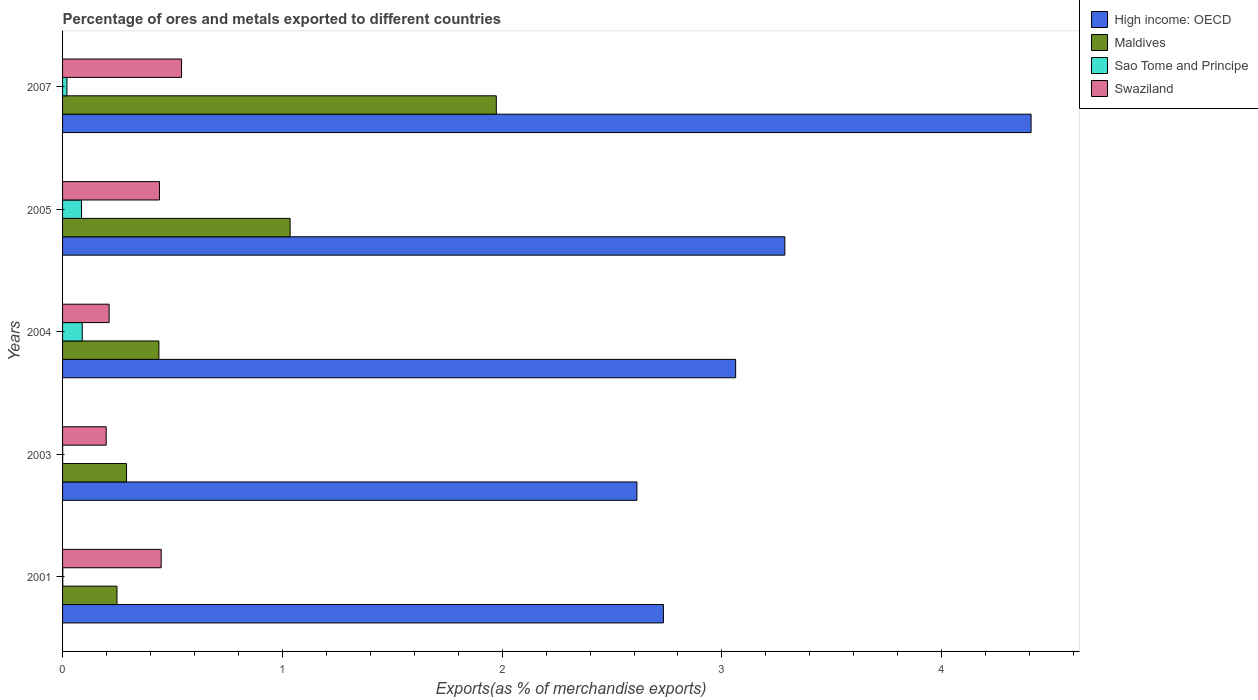How many different coloured bars are there?
Make the answer very short. 4. How many bars are there on the 4th tick from the top?
Provide a short and direct response. 4. How many bars are there on the 4th tick from the bottom?
Provide a short and direct response. 4. In how many cases, is the number of bars for a given year not equal to the number of legend labels?
Make the answer very short. 0. What is the percentage of exports to different countries in High income: OECD in 2007?
Provide a short and direct response. 4.41. Across all years, what is the maximum percentage of exports to different countries in Swaziland?
Your response must be concise. 0.54. Across all years, what is the minimum percentage of exports to different countries in Swaziland?
Offer a terse response. 0.2. In which year was the percentage of exports to different countries in Swaziland maximum?
Give a very brief answer. 2007. What is the total percentage of exports to different countries in Sao Tome and Principe in the graph?
Make the answer very short. 0.2. What is the difference between the percentage of exports to different countries in Swaziland in 2003 and that in 2004?
Ensure brevity in your answer.  -0.01. What is the difference between the percentage of exports to different countries in Swaziland in 2001 and the percentage of exports to different countries in Maldives in 2003?
Offer a terse response. 0.16. What is the average percentage of exports to different countries in High income: OECD per year?
Provide a short and direct response. 3.22. In the year 2003, what is the difference between the percentage of exports to different countries in Swaziland and percentage of exports to different countries in Maldives?
Keep it short and to the point. -0.09. What is the ratio of the percentage of exports to different countries in High income: OECD in 2001 to that in 2003?
Offer a very short reply. 1.05. What is the difference between the highest and the second highest percentage of exports to different countries in Sao Tome and Principe?
Your answer should be very brief. 0. What is the difference between the highest and the lowest percentage of exports to different countries in Swaziland?
Make the answer very short. 0.34. Is the sum of the percentage of exports to different countries in Maldives in 2001 and 2004 greater than the maximum percentage of exports to different countries in High income: OECD across all years?
Offer a very short reply. No. Is it the case that in every year, the sum of the percentage of exports to different countries in Sao Tome and Principe and percentage of exports to different countries in High income: OECD is greater than the sum of percentage of exports to different countries in Maldives and percentage of exports to different countries in Swaziland?
Keep it short and to the point. Yes. What does the 2nd bar from the top in 2004 represents?
Offer a very short reply. Sao Tome and Principe. What does the 1st bar from the bottom in 2007 represents?
Provide a succinct answer. High income: OECD. Is it the case that in every year, the sum of the percentage of exports to different countries in Swaziland and percentage of exports to different countries in Maldives is greater than the percentage of exports to different countries in Sao Tome and Principe?
Offer a very short reply. Yes. How many bars are there?
Give a very brief answer. 20. How many legend labels are there?
Make the answer very short. 4. What is the title of the graph?
Offer a very short reply. Percentage of ores and metals exported to different countries. What is the label or title of the X-axis?
Ensure brevity in your answer.  Exports(as % of merchandise exports). What is the label or title of the Y-axis?
Ensure brevity in your answer.  Years. What is the Exports(as % of merchandise exports) in High income: OECD in 2001?
Offer a terse response. 2.73. What is the Exports(as % of merchandise exports) of Maldives in 2001?
Your response must be concise. 0.25. What is the Exports(as % of merchandise exports) of Sao Tome and Principe in 2001?
Your response must be concise. 0. What is the Exports(as % of merchandise exports) in Swaziland in 2001?
Provide a succinct answer. 0.45. What is the Exports(as % of merchandise exports) of High income: OECD in 2003?
Ensure brevity in your answer.  2.61. What is the Exports(as % of merchandise exports) in Maldives in 2003?
Keep it short and to the point. 0.29. What is the Exports(as % of merchandise exports) of Sao Tome and Principe in 2003?
Ensure brevity in your answer.  0. What is the Exports(as % of merchandise exports) in Swaziland in 2003?
Ensure brevity in your answer.  0.2. What is the Exports(as % of merchandise exports) of High income: OECD in 2004?
Make the answer very short. 3.06. What is the Exports(as % of merchandise exports) of Maldives in 2004?
Offer a terse response. 0.44. What is the Exports(as % of merchandise exports) of Sao Tome and Principe in 2004?
Ensure brevity in your answer.  0.09. What is the Exports(as % of merchandise exports) of Swaziland in 2004?
Offer a terse response. 0.21. What is the Exports(as % of merchandise exports) in High income: OECD in 2005?
Your response must be concise. 3.29. What is the Exports(as % of merchandise exports) of Maldives in 2005?
Your answer should be very brief. 1.04. What is the Exports(as % of merchandise exports) in Sao Tome and Principe in 2005?
Offer a terse response. 0.09. What is the Exports(as % of merchandise exports) of Swaziland in 2005?
Give a very brief answer. 0.44. What is the Exports(as % of merchandise exports) in High income: OECD in 2007?
Your answer should be very brief. 4.41. What is the Exports(as % of merchandise exports) in Maldives in 2007?
Give a very brief answer. 1.97. What is the Exports(as % of merchandise exports) of Sao Tome and Principe in 2007?
Your response must be concise. 0.02. What is the Exports(as % of merchandise exports) in Swaziland in 2007?
Make the answer very short. 0.54. Across all years, what is the maximum Exports(as % of merchandise exports) of High income: OECD?
Your answer should be very brief. 4.41. Across all years, what is the maximum Exports(as % of merchandise exports) of Maldives?
Make the answer very short. 1.97. Across all years, what is the maximum Exports(as % of merchandise exports) in Sao Tome and Principe?
Your response must be concise. 0.09. Across all years, what is the maximum Exports(as % of merchandise exports) in Swaziland?
Keep it short and to the point. 0.54. Across all years, what is the minimum Exports(as % of merchandise exports) of High income: OECD?
Offer a terse response. 2.61. Across all years, what is the minimum Exports(as % of merchandise exports) in Maldives?
Offer a terse response. 0.25. Across all years, what is the minimum Exports(as % of merchandise exports) in Sao Tome and Principe?
Your answer should be compact. 0. Across all years, what is the minimum Exports(as % of merchandise exports) in Swaziland?
Give a very brief answer. 0.2. What is the total Exports(as % of merchandise exports) of High income: OECD in the graph?
Offer a very short reply. 16.1. What is the total Exports(as % of merchandise exports) in Maldives in the graph?
Your response must be concise. 3.99. What is the total Exports(as % of merchandise exports) of Sao Tome and Principe in the graph?
Your response must be concise. 0.2. What is the total Exports(as % of merchandise exports) in Swaziland in the graph?
Your answer should be very brief. 1.84. What is the difference between the Exports(as % of merchandise exports) of High income: OECD in 2001 and that in 2003?
Offer a very short reply. 0.12. What is the difference between the Exports(as % of merchandise exports) of Maldives in 2001 and that in 2003?
Ensure brevity in your answer.  -0.04. What is the difference between the Exports(as % of merchandise exports) of Sao Tome and Principe in 2001 and that in 2003?
Your answer should be compact. 0. What is the difference between the Exports(as % of merchandise exports) of Swaziland in 2001 and that in 2003?
Give a very brief answer. 0.25. What is the difference between the Exports(as % of merchandise exports) in High income: OECD in 2001 and that in 2004?
Your answer should be very brief. -0.33. What is the difference between the Exports(as % of merchandise exports) in Maldives in 2001 and that in 2004?
Provide a short and direct response. -0.19. What is the difference between the Exports(as % of merchandise exports) in Sao Tome and Principe in 2001 and that in 2004?
Your answer should be very brief. -0.09. What is the difference between the Exports(as % of merchandise exports) of Swaziland in 2001 and that in 2004?
Make the answer very short. 0.24. What is the difference between the Exports(as % of merchandise exports) in High income: OECD in 2001 and that in 2005?
Keep it short and to the point. -0.55. What is the difference between the Exports(as % of merchandise exports) in Maldives in 2001 and that in 2005?
Your response must be concise. -0.79. What is the difference between the Exports(as % of merchandise exports) in Sao Tome and Principe in 2001 and that in 2005?
Offer a terse response. -0.09. What is the difference between the Exports(as % of merchandise exports) in Swaziland in 2001 and that in 2005?
Make the answer very short. 0.01. What is the difference between the Exports(as % of merchandise exports) of High income: OECD in 2001 and that in 2007?
Offer a terse response. -1.67. What is the difference between the Exports(as % of merchandise exports) of Maldives in 2001 and that in 2007?
Your answer should be very brief. -1.73. What is the difference between the Exports(as % of merchandise exports) of Sao Tome and Principe in 2001 and that in 2007?
Offer a terse response. -0.02. What is the difference between the Exports(as % of merchandise exports) of Swaziland in 2001 and that in 2007?
Make the answer very short. -0.09. What is the difference between the Exports(as % of merchandise exports) of High income: OECD in 2003 and that in 2004?
Give a very brief answer. -0.45. What is the difference between the Exports(as % of merchandise exports) of Maldives in 2003 and that in 2004?
Offer a terse response. -0.15. What is the difference between the Exports(as % of merchandise exports) of Sao Tome and Principe in 2003 and that in 2004?
Ensure brevity in your answer.  -0.09. What is the difference between the Exports(as % of merchandise exports) of Swaziland in 2003 and that in 2004?
Provide a short and direct response. -0.01. What is the difference between the Exports(as % of merchandise exports) in High income: OECD in 2003 and that in 2005?
Offer a terse response. -0.67. What is the difference between the Exports(as % of merchandise exports) in Maldives in 2003 and that in 2005?
Offer a terse response. -0.74. What is the difference between the Exports(as % of merchandise exports) in Sao Tome and Principe in 2003 and that in 2005?
Your answer should be very brief. -0.09. What is the difference between the Exports(as % of merchandise exports) of Swaziland in 2003 and that in 2005?
Offer a very short reply. -0.24. What is the difference between the Exports(as % of merchandise exports) in High income: OECD in 2003 and that in 2007?
Give a very brief answer. -1.79. What is the difference between the Exports(as % of merchandise exports) in Maldives in 2003 and that in 2007?
Make the answer very short. -1.68. What is the difference between the Exports(as % of merchandise exports) of Sao Tome and Principe in 2003 and that in 2007?
Your answer should be very brief. -0.02. What is the difference between the Exports(as % of merchandise exports) in Swaziland in 2003 and that in 2007?
Offer a very short reply. -0.34. What is the difference between the Exports(as % of merchandise exports) in High income: OECD in 2004 and that in 2005?
Your answer should be compact. -0.22. What is the difference between the Exports(as % of merchandise exports) in Maldives in 2004 and that in 2005?
Make the answer very short. -0.6. What is the difference between the Exports(as % of merchandise exports) in Sao Tome and Principe in 2004 and that in 2005?
Keep it short and to the point. 0. What is the difference between the Exports(as % of merchandise exports) of Swaziland in 2004 and that in 2005?
Offer a very short reply. -0.23. What is the difference between the Exports(as % of merchandise exports) of High income: OECD in 2004 and that in 2007?
Ensure brevity in your answer.  -1.34. What is the difference between the Exports(as % of merchandise exports) of Maldives in 2004 and that in 2007?
Give a very brief answer. -1.54. What is the difference between the Exports(as % of merchandise exports) in Sao Tome and Principe in 2004 and that in 2007?
Your answer should be compact. 0.07. What is the difference between the Exports(as % of merchandise exports) in Swaziland in 2004 and that in 2007?
Keep it short and to the point. -0.33. What is the difference between the Exports(as % of merchandise exports) of High income: OECD in 2005 and that in 2007?
Your answer should be compact. -1.12. What is the difference between the Exports(as % of merchandise exports) of Maldives in 2005 and that in 2007?
Offer a very short reply. -0.94. What is the difference between the Exports(as % of merchandise exports) of Sao Tome and Principe in 2005 and that in 2007?
Your answer should be compact. 0.07. What is the difference between the Exports(as % of merchandise exports) in Swaziland in 2005 and that in 2007?
Provide a short and direct response. -0.1. What is the difference between the Exports(as % of merchandise exports) in High income: OECD in 2001 and the Exports(as % of merchandise exports) in Maldives in 2003?
Your response must be concise. 2.44. What is the difference between the Exports(as % of merchandise exports) in High income: OECD in 2001 and the Exports(as % of merchandise exports) in Sao Tome and Principe in 2003?
Give a very brief answer. 2.73. What is the difference between the Exports(as % of merchandise exports) in High income: OECD in 2001 and the Exports(as % of merchandise exports) in Swaziland in 2003?
Provide a short and direct response. 2.54. What is the difference between the Exports(as % of merchandise exports) of Maldives in 2001 and the Exports(as % of merchandise exports) of Sao Tome and Principe in 2003?
Provide a succinct answer. 0.25. What is the difference between the Exports(as % of merchandise exports) of Maldives in 2001 and the Exports(as % of merchandise exports) of Swaziland in 2003?
Provide a succinct answer. 0.05. What is the difference between the Exports(as % of merchandise exports) of Sao Tome and Principe in 2001 and the Exports(as % of merchandise exports) of Swaziland in 2003?
Make the answer very short. -0.2. What is the difference between the Exports(as % of merchandise exports) in High income: OECD in 2001 and the Exports(as % of merchandise exports) in Maldives in 2004?
Give a very brief answer. 2.3. What is the difference between the Exports(as % of merchandise exports) of High income: OECD in 2001 and the Exports(as % of merchandise exports) of Sao Tome and Principe in 2004?
Keep it short and to the point. 2.64. What is the difference between the Exports(as % of merchandise exports) in High income: OECD in 2001 and the Exports(as % of merchandise exports) in Swaziland in 2004?
Make the answer very short. 2.52. What is the difference between the Exports(as % of merchandise exports) of Maldives in 2001 and the Exports(as % of merchandise exports) of Sao Tome and Principe in 2004?
Your answer should be very brief. 0.16. What is the difference between the Exports(as % of merchandise exports) in Maldives in 2001 and the Exports(as % of merchandise exports) in Swaziland in 2004?
Ensure brevity in your answer.  0.04. What is the difference between the Exports(as % of merchandise exports) of Sao Tome and Principe in 2001 and the Exports(as % of merchandise exports) of Swaziland in 2004?
Your answer should be compact. -0.21. What is the difference between the Exports(as % of merchandise exports) of High income: OECD in 2001 and the Exports(as % of merchandise exports) of Maldives in 2005?
Keep it short and to the point. 1.7. What is the difference between the Exports(as % of merchandise exports) of High income: OECD in 2001 and the Exports(as % of merchandise exports) of Sao Tome and Principe in 2005?
Provide a short and direct response. 2.65. What is the difference between the Exports(as % of merchandise exports) in High income: OECD in 2001 and the Exports(as % of merchandise exports) in Swaziland in 2005?
Make the answer very short. 2.29. What is the difference between the Exports(as % of merchandise exports) of Maldives in 2001 and the Exports(as % of merchandise exports) of Sao Tome and Principe in 2005?
Your response must be concise. 0.16. What is the difference between the Exports(as % of merchandise exports) of Maldives in 2001 and the Exports(as % of merchandise exports) of Swaziland in 2005?
Your answer should be compact. -0.19. What is the difference between the Exports(as % of merchandise exports) of Sao Tome and Principe in 2001 and the Exports(as % of merchandise exports) of Swaziland in 2005?
Offer a very short reply. -0.44. What is the difference between the Exports(as % of merchandise exports) in High income: OECD in 2001 and the Exports(as % of merchandise exports) in Maldives in 2007?
Your response must be concise. 0.76. What is the difference between the Exports(as % of merchandise exports) of High income: OECD in 2001 and the Exports(as % of merchandise exports) of Sao Tome and Principe in 2007?
Offer a terse response. 2.71. What is the difference between the Exports(as % of merchandise exports) in High income: OECD in 2001 and the Exports(as % of merchandise exports) in Swaziland in 2007?
Offer a terse response. 2.19. What is the difference between the Exports(as % of merchandise exports) of Maldives in 2001 and the Exports(as % of merchandise exports) of Sao Tome and Principe in 2007?
Your response must be concise. 0.23. What is the difference between the Exports(as % of merchandise exports) of Maldives in 2001 and the Exports(as % of merchandise exports) of Swaziland in 2007?
Your response must be concise. -0.29. What is the difference between the Exports(as % of merchandise exports) in Sao Tome and Principe in 2001 and the Exports(as % of merchandise exports) in Swaziland in 2007?
Ensure brevity in your answer.  -0.54. What is the difference between the Exports(as % of merchandise exports) in High income: OECD in 2003 and the Exports(as % of merchandise exports) in Maldives in 2004?
Your answer should be compact. 2.17. What is the difference between the Exports(as % of merchandise exports) in High income: OECD in 2003 and the Exports(as % of merchandise exports) in Sao Tome and Principe in 2004?
Offer a very short reply. 2.52. What is the difference between the Exports(as % of merchandise exports) in High income: OECD in 2003 and the Exports(as % of merchandise exports) in Swaziland in 2004?
Provide a short and direct response. 2.4. What is the difference between the Exports(as % of merchandise exports) of Maldives in 2003 and the Exports(as % of merchandise exports) of Sao Tome and Principe in 2004?
Provide a short and direct response. 0.2. What is the difference between the Exports(as % of merchandise exports) in Maldives in 2003 and the Exports(as % of merchandise exports) in Swaziland in 2004?
Your answer should be compact. 0.08. What is the difference between the Exports(as % of merchandise exports) of Sao Tome and Principe in 2003 and the Exports(as % of merchandise exports) of Swaziland in 2004?
Provide a short and direct response. -0.21. What is the difference between the Exports(as % of merchandise exports) in High income: OECD in 2003 and the Exports(as % of merchandise exports) in Maldives in 2005?
Make the answer very short. 1.58. What is the difference between the Exports(as % of merchandise exports) of High income: OECD in 2003 and the Exports(as % of merchandise exports) of Sao Tome and Principe in 2005?
Ensure brevity in your answer.  2.53. What is the difference between the Exports(as % of merchandise exports) of High income: OECD in 2003 and the Exports(as % of merchandise exports) of Swaziland in 2005?
Offer a terse response. 2.17. What is the difference between the Exports(as % of merchandise exports) of Maldives in 2003 and the Exports(as % of merchandise exports) of Sao Tome and Principe in 2005?
Offer a very short reply. 0.2. What is the difference between the Exports(as % of merchandise exports) of Maldives in 2003 and the Exports(as % of merchandise exports) of Swaziland in 2005?
Make the answer very short. -0.15. What is the difference between the Exports(as % of merchandise exports) of Sao Tome and Principe in 2003 and the Exports(as % of merchandise exports) of Swaziland in 2005?
Offer a very short reply. -0.44. What is the difference between the Exports(as % of merchandise exports) in High income: OECD in 2003 and the Exports(as % of merchandise exports) in Maldives in 2007?
Your answer should be compact. 0.64. What is the difference between the Exports(as % of merchandise exports) in High income: OECD in 2003 and the Exports(as % of merchandise exports) in Sao Tome and Principe in 2007?
Give a very brief answer. 2.59. What is the difference between the Exports(as % of merchandise exports) of High income: OECD in 2003 and the Exports(as % of merchandise exports) of Swaziland in 2007?
Provide a succinct answer. 2.07. What is the difference between the Exports(as % of merchandise exports) in Maldives in 2003 and the Exports(as % of merchandise exports) in Sao Tome and Principe in 2007?
Give a very brief answer. 0.27. What is the difference between the Exports(as % of merchandise exports) in Maldives in 2003 and the Exports(as % of merchandise exports) in Swaziland in 2007?
Make the answer very short. -0.25. What is the difference between the Exports(as % of merchandise exports) in Sao Tome and Principe in 2003 and the Exports(as % of merchandise exports) in Swaziland in 2007?
Offer a terse response. -0.54. What is the difference between the Exports(as % of merchandise exports) of High income: OECD in 2004 and the Exports(as % of merchandise exports) of Maldives in 2005?
Ensure brevity in your answer.  2.03. What is the difference between the Exports(as % of merchandise exports) in High income: OECD in 2004 and the Exports(as % of merchandise exports) in Sao Tome and Principe in 2005?
Provide a succinct answer. 2.98. What is the difference between the Exports(as % of merchandise exports) of High income: OECD in 2004 and the Exports(as % of merchandise exports) of Swaziland in 2005?
Provide a short and direct response. 2.62. What is the difference between the Exports(as % of merchandise exports) in Maldives in 2004 and the Exports(as % of merchandise exports) in Sao Tome and Principe in 2005?
Offer a terse response. 0.35. What is the difference between the Exports(as % of merchandise exports) of Maldives in 2004 and the Exports(as % of merchandise exports) of Swaziland in 2005?
Your response must be concise. -0. What is the difference between the Exports(as % of merchandise exports) of Sao Tome and Principe in 2004 and the Exports(as % of merchandise exports) of Swaziland in 2005?
Give a very brief answer. -0.35. What is the difference between the Exports(as % of merchandise exports) of High income: OECD in 2004 and the Exports(as % of merchandise exports) of Maldives in 2007?
Your response must be concise. 1.09. What is the difference between the Exports(as % of merchandise exports) of High income: OECD in 2004 and the Exports(as % of merchandise exports) of Sao Tome and Principe in 2007?
Keep it short and to the point. 3.04. What is the difference between the Exports(as % of merchandise exports) in High income: OECD in 2004 and the Exports(as % of merchandise exports) in Swaziland in 2007?
Keep it short and to the point. 2.52. What is the difference between the Exports(as % of merchandise exports) of Maldives in 2004 and the Exports(as % of merchandise exports) of Sao Tome and Principe in 2007?
Provide a short and direct response. 0.42. What is the difference between the Exports(as % of merchandise exports) in Maldives in 2004 and the Exports(as % of merchandise exports) in Swaziland in 2007?
Make the answer very short. -0.1. What is the difference between the Exports(as % of merchandise exports) in Sao Tome and Principe in 2004 and the Exports(as % of merchandise exports) in Swaziland in 2007?
Provide a short and direct response. -0.45. What is the difference between the Exports(as % of merchandise exports) of High income: OECD in 2005 and the Exports(as % of merchandise exports) of Maldives in 2007?
Provide a succinct answer. 1.31. What is the difference between the Exports(as % of merchandise exports) of High income: OECD in 2005 and the Exports(as % of merchandise exports) of Sao Tome and Principe in 2007?
Offer a very short reply. 3.27. What is the difference between the Exports(as % of merchandise exports) in High income: OECD in 2005 and the Exports(as % of merchandise exports) in Swaziland in 2007?
Your answer should be very brief. 2.74. What is the difference between the Exports(as % of merchandise exports) in Maldives in 2005 and the Exports(as % of merchandise exports) in Sao Tome and Principe in 2007?
Make the answer very short. 1.02. What is the difference between the Exports(as % of merchandise exports) of Maldives in 2005 and the Exports(as % of merchandise exports) of Swaziland in 2007?
Give a very brief answer. 0.49. What is the difference between the Exports(as % of merchandise exports) in Sao Tome and Principe in 2005 and the Exports(as % of merchandise exports) in Swaziland in 2007?
Your answer should be very brief. -0.46. What is the average Exports(as % of merchandise exports) of High income: OECD per year?
Make the answer very short. 3.22. What is the average Exports(as % of merchandise exports) of Maldives per year?
Make the answer very short. 0.8. What is the average Exports(as % of merchandise exports) of Sao Tome and Principe per year?
Keep it short and to the point. 0.04. What is the average Exports(as % of merchandise exports) of Swaziland per year?
Offer a terse response. 0.37. In the year 2001, what is the difference between the Exports(as % of merchandise exports) in High income: OECD and Exports(as % of merchandise exports) in Maldives?
Your response must be concise. 2.49. In the year 2001, what is the difference between the Exports(as % of merchandise exports) of High income: OECD and Exports(as % of merchandise exports) of Sao Tome and Principe?
Your response must be concise. 2.73. In the year 2001, what is the difference between the Exports(as % of merchandise exports) in High income: OECD and Exports(as % of merchandise exports) in Swaziland?
Ensure brevity in your answer.  2.29. In the year 2001, what is the difference between the Exports(as % of merchandise exports) in Maldives and Exports(as % of merchandise exports) in Sao Tome and Principe?
Keep it short and to the point. 0.25. In the year 2001, what is the difference between the Exports(as % of merchandise exports) of Maldives and Exports(as % of merchandise exports) of Swaziland?
Keep it short and to the point. -0.2. In the year 2001, what is the difference between the Exports(as % of merchandise exports) in Sao Tome and Principe and Exports(as % of merchandise exports) in Swaziland?
Ensure brevity in your answer.  -0.45. In the year 2003, what is the difference between the Exports(as % of merchandise exports) in High income: OECD and Exports(as % of merchandise exports) in Maldives?
Give a very brief answer. 2.32. In the year 2003, what is the difference between the Exports(as % of merchandise exports) of High income: OECD and Exports(as % of merchandise exports) of Sao Tome and Principe?
Provide a succinct answer. 2.61. In the year 2003, what is the difference between the Exports(as % of merchandise exports) in High income: OECD and Exports(as % of merchandise exports) in Swaziland?
Give a very brief answer. 2.41. In the year 2003, what is the difference between the Exports(as % of merchandise exports) of Maldives and Exports(as % of merchandise exports) of Sao Tome and Principe?
Keep it short and to the point. 0.29. In the year 2003, what is the difference between the Exports(as % of merchandise exports) in Maldives and Exports(as % of merchandise exports) in Swaziland?
Your answer should be very brief. 0.09. In the year 2003, what is the difference between the Exports(as % of merchandise exports) in Sao Tome and Principe and Exports(as % of merchandise exports) in Swaziland?
Offer a terse response. -0.2. In the year 2004, what is the difference between the Exports(as % of merchandise exports) in High income: OECD and Exports(as % of merchandise exports) in Maldives?
Your answer should be very brief. 2.62. In the year 2004, what is the difference between the Exports(as % of merchandise exports) of High income: OECD and Exports(as % of merchandise exports) of Sao Tome and Principe?
Provide a short and direct response. 2.97. In the year 2004, what is the difference between the Exports(as % of merchandise exports) in High income: OECD and Exports(as % of merchandise exports) in Swaziland?
Keep it short and to the point. 2.85. In the year 2004, what is the difference between the Exports(as % of merchandise exports) in Maldives and Exports(as % of merchandise exports) in Sao Tome and Principe?
Your answer should be very brief. 0.35. In the year 2004, what is the difference between the Exports(as % of merchandise exports) in Maldives and Exports(as % of merchandise exports) in Swaziland?
Provide a succinct answer. 0.23. In the year 2004, what is the difference between the Exports(as % of merchandise exports) in Sao Tome and Principe and Exports(as % of merchandise exports) in Swaziland?
Give a very brief answer. -0.12. In the year 2005, what is the difference between the Exports(as % of merchandise exports) of High income: OECD and Exports(as % of merchandise exports) of Maldives?
Offer a terse response. 2.25. In the year 2005, what is the difference between the Exports(as % of merchandise exports) of High income: OECD and Exports(as % of merchandise exports) of Sao Tome and Principe?
Provide a short and direct response. 3.2. In the year 2005, what is the difference between the Exports(as % of merchandise exports) in High income: OECD and Exports(as % of merchandise exports) in Swaziland?
Give a very brief answer. 2.85. In the year 2005, what is the difference between the Exports(as % of merchandise exports) in Maldives and Exports(as % of merchandise exports) in Sao Tome and Principe?
Your answer should be compact. 0.95. In the year 2005, what is the difference between the Exports(as % of merchandise exports) of Maldives and Exports(as % of merchandise exports) of Swaziland?
Offer a very short reply. 0.59. In the year 2005, what is the difference between the Exports(as % of merchandise exports) in Sao Tome and Principe and Exports(as % of merchandise exports) in Swaziland?
Provide a succinct answer. -0.35. In the year 2007, what is the difference between the Exports(as % of merchandise exports) in High income: OECD and Exports(as % of merchandise exports) in Maldives?
Give a very brief answer. 2.43. In the year 2007, what is the difference between the Exports(as % of merchandise exports) of High income: OECD and Exports(as % of merchandise exports) of Sao Tome and Principe?
Ensure brevity in your answer.  4.39. In the year 2007, what is the difference between the Exports(as % of merchandise exports) in High income: OECD and Exports(as % of merchandise exports) in Swaziland?
Ensure brevity in your answer.  3.87. In the year 2007, what is the difference between the Exports(as % of merchandise exports) in Maldives and Exports(as % of merchandise exports) in Sao Tome and Principe?
Offer a very short reply. 1.95. In the year 2007, what is the difference between the Exports(as % of merchandise exports) of Maldives and Exports(as % of merchandise exports) of Swaziland?
Keep it short and to the point. 1.43. In the year 2007, what is the difference between the Exports(as % of merchandise exports) of Sao Tome and Principe and Exports(as % of merchandise exports) of Swaziland?
Keep it short and to the point. -0.52. What is the ratio of the Exports(as % of merchandise exports) in High income: OECD in 2001 to that in 2003?
Provide a short and direct response. 1.05. What is the ratio of the Exports(as % of merchandise exports) in Maldives in 2001 to that in 2003?
Your response must be concise. 0.85. What is the ratio of the Exports(as % of merchandise exports) in Sao Tome and Principe in 2001 to that in 2003?
Give a very brief answer. 3.37. What is the ratio of the Exports(as % of merchandise exports) of Swaziland in 2001 to that in 2003?
Provide a succinct answer. 2.26. What is the ratio of the Exports(as % of merchandise exports) in High income: OECD in 2001 to that in 2004?
Provide a short and direct response. 0.89. What is the ratio of the Exports(as % of merchandise exports) in Maldives in 2001 to that in 2004?
Your answer should be compact. 0.56. What is the ratio of the Exports(as % of merchandise exports) in Sao Tome and Principe in 2001 to that in 2004?
Offer a terse response. 0.01. What is the ratio of the Exports(as % of merchandise exports) of Swaziland in 2001 to that in 2004?
Ensure brevity in your answer.  2.12. What is the ratio of the Exports(as % of merchandise exports) in High income: OECD in 2001 to that in 2005?
Your answer should be very brief. 0.83. What is the ratio of the Exports(as % of merchandise exports) of Maldives in 2001 to that in 2005?
Offer a very short reply. 0.24. What is the ratio of the Exports(as % of merchandise exports) of Sao Tome and Principe in 2001 to that in 2005?
Offer a terse response. 0.01. What is the ratio of the Exports(as % of merchandise exports) in Swaziland in 2001 to that in 2005?
Your answer should be very brief. 1.02. What is the ratio of the Exports(as % of merchandise exports) of High income: OECD in 2001 to that in 2007?
Your answer should be compact. 0.62. What is the ratio of the Exports(as % of merchandise exports) of Maldives in 2001 to that in 2007?
Your answer should be compact. 0.13. What is the ratio of the Exports(as % of merchandise exports) of Sao Tome and Principe in 2001 to that in 2007?
Make the answer very short. 0.05. What is the ratio of the Exports(as % of merchandise exports) in Swaziland in 2001 to that in 2007?
Your answer should be compact. 0.83. What is the ratio of the Exports(as % of merchandise exports) in High income: OECD in 2003 to that in 2004?
Offer a very short reply. 0.85. What is the ratio of the Exports(as % of merchandise exports) in Maldives in 2003 to that in 2004?
Offer a very short reply. 0.66. What is the ratio of the Exports(as % of merchandise exports) in Sao Tome and Principe in 2003 to that in 2004?
Keep it short and to the point. 0. What is the ratio of the Exports(as % of merchandise exports) of Swaziland in 2003 to that in 2004?
Your answer should be compact. 0.94. What is the ratio of the Exports(as % of merchandise exports) of High income: OECD in 2003 to that in 2005?
Provide a succinct answer. 0.8. What is the ratio of the Exports(as % of merchandise exports) in Maldives in 2003 to that in 2005?
Keep it short and to the point. 0.28. What is the ratio of the Exports(as % of merchandise exports) of Sao Tome and Principe in 2003 to that in 2005?
Offer a terse response. 0. What is the ratio of the Exports(as % of merchandise exports) in Swaziland in 2003 to that in 2005?
Your response must be concise. 0.45. What is the ratio of the Exports(as % of merchandise exports) in High income: OECD in 2003 to that in 2007?
Offer a terse response. 0.59. What is the ratio of the Exports(as % of merchandise exports) of Maldives in 2003 to that in 2007?
Ensure brevity in your answer.  0.15. What is the ratio of the Exports(as % of merchandise exports) in Sao Tome and Principe in 2003 to that in 2007?
Your answer should be compact. 0.02. What is the ratio of the Exports(as % of merchandise exports) of Swaziland in 2003 to that in 2007?
Keep it short and to the point. 0.37. What is the ratio of the Exports(as % of merchandise exports) in High income: OECD in 2004 to that in 2005?
Your answer should be compact. 0.93. What is the ratio of the Exports(as % of merchandise exports) of Maldives in 2004 to that in 2005?
Keep it short and to the point. 0.42. What is the ratio of the Exports(as % of merchandise exports) in Sao Tome and Principe in 2004 to that in 2005?
Keep it short and to the point. 1.04. What is the ratio of the Exports(as % of merchandise exports) in Swaziland in 2004 to that in 2005?
Your response must be concise. 0.48. What is the ratio of the Exports(as % of merchandise exports) of High income: OECD in 2004 to that in 2007?
Ensure brevity in your answer.  0.69. What is the ratio of the Exports(as % of merchandise exports) in Maldives in 2004 to that in 2007?
Provide a succinct answer. 0.22. What is the ratio of the Exports(as % of merchandise exports) in Sao Tome and Principe in 2004 to that in 2007?
Your answer should be very brief. 4.51. What is the ratio of the Exports(as % of merchandise exports) of Swaziland in 2004 to that in 2007?
Make the answer very short. 0.39. What is the ratio of the Exports(as % of merchandise exports) in High income: OECD in 2005 to that in 2007?
Provide a succinct answer. 0.75. What is the ratio of the Exports(as % of merchandise exports) in Maldives in 2005 to that in 2007?
Give a very brief answer. 0.52. What is the ratio of the Exports(as % of merchandise exports) in Sao Tome and Principe in 2005 to that in 2007?
Your response must be concise. 4.35. What is the ratio of the Exports(as % of merchandise exports) of Swaziland in 2005 to that in 2007?
Give a very brief answer. 0.81. What is the difference between the highest and the second highest Exports(as % of merchandise exports) of High income: OECD?
Keep it short and to the point. 1.12. What is the difference between the highest and the second highest Exports(as % of merchandise exports) of Maldives?
Offer a terse response. 0.94. What is the difference between the highest and the second highest Exports(as % of merchandise exports) in Sao Tome and Principe?
Provide a succinct answer. 0. What is the difference between the highest and the second highest Exports(as % of merchandise exports) of Swaziland?
Offer a terse response. 0.09. What is the difference between the highest and the lowest Exports(as % of merchandise exports) of High income: OECD?
Ensure brevity in your answer.  1.79. What is the difference between the highest and the lowest Exports(as % of merchandise exports) in Maldives?
Make the answer very short. 1.73. What is the difference between the highest and the lowest Exports(as % of merchandise exports) in Sao Tome and Principe?
Provide a succinct answer. 0.09. What is the difference between the highest and the lowest Exports(as % of merchandise exports) of Swaziland?
Your response must be concise. 0.34. 